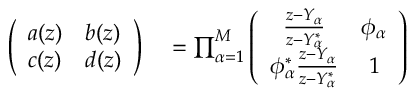<formula> <loc_0><loc_0><loc_500><loc_500>\begin{array} { r l } { \left ( \begin{array} { l l } { a ( z ) } & { b ( z ) } \\ { c ( z ) } & { d ( z ) } \end{array} \right ) } & = \prod _ { \alpha = 1 } ^ { M } \left ( \begin{array} { c c } { \frac { z - Y _ { \alpha } } { z - Y _ { \alpha } ^ { * } } } & { \phi _ { \alpha } } \\ { \phi _ { \alpha } ^ { * } \frac { z - Y _ { \alpha } } { z - Y _ { \alpha } ^ { * } } } & { 1 } \end{array} \right ) } \end{array}</formula> 